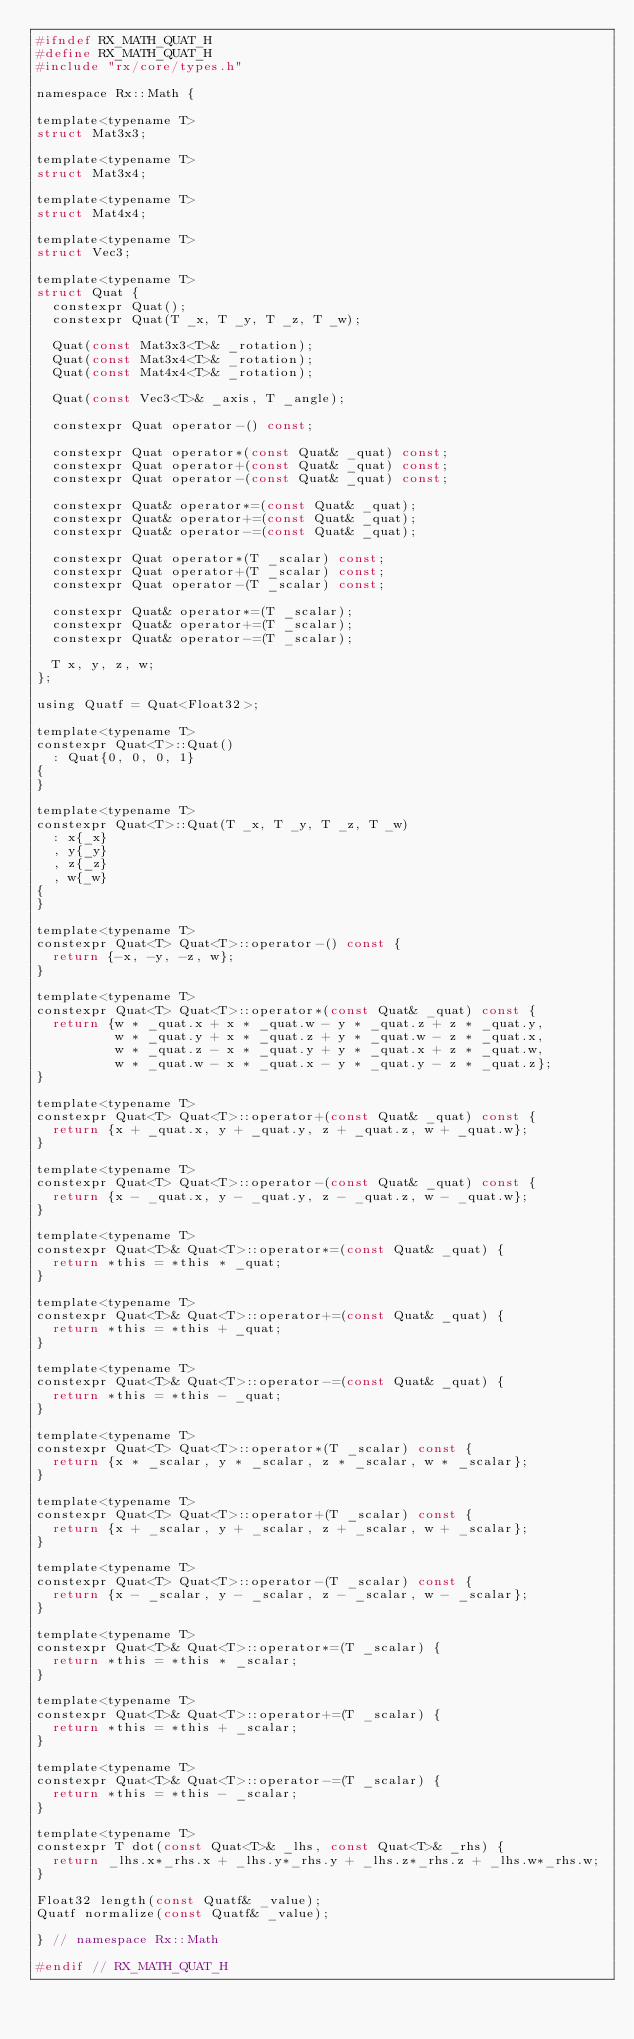Convert code to text. <code><loc_0><loc_0><loc_500><loc_500><_C_>#ifndef RX_MATH_QUAT_H
#define RX_MATH_QUAT_H
#include "rx/core/types.h"

namespace Rx::Math {

template<typename T>
struct Mat3x3;

template<typename T>
struct Mat3x4;

template<typename T>
struct Mat4x4;

template<typename T>
struct Vec3;

template<typename T>
struct Quat {
  constexpr Quat();
  constexpr Quat(T _x, T _y, T _z, T _w);

  Quat(const Mat3x3<T>& _rotation);
  Quat(const Mat3x4<T>& _rotation);
  Quat(const Mat4x4<T>& _rotation);

  Quat(const Vec3<T>& _axis, T _angle);

  constexpr Quat operator-() const;

  constexpr Quat operator*(const Quat& _quat) const;
  constexpr Quat operator+(const Quat& _quat) const;
  constexpr Quat operator-(const Quat& _quat) const;

  constexpr Quat& operator*=(const Quat& _quat);
  constexpr Quat& operator+=(const Quat& _quat);
  constexpr Quat& operator-=(const Quat& _quat);

  constexpr Quat operator*(T _scalar) const;
  constexpr Quat operator+(T _scalar) const;
  constexpr Quat operator-(T _scalar) const;

  constexpr Quat& operator*=(T _scalar);
  constexpr Quat& operator+=(T _scalar);
  constexpr Quat& operator-=(T _scalar);

  T x, y, z, w;
};

using Quatf = Quat<Float32>;

template<typename T>
constexpr Quat<T>::Quat()
  : Quat{0, 0, 0, 1}
{
}

template<typename T>
constexpr Quat<T>::Quat(T _x, T _y, T _z, T _w)
  : x{_x}
  , y{_y}
  , z{_z}
  , w{_w}
{
}

template<typename T>
constexpr Quat<T> Quat<T>::operator-() const {
  return {-x, -y, -z, w};
}

template<typename T>
constexpr Quat<T> Quat<T>::operator*(const Quat& _quat) const {
  return {w * _quat.x + x * _quat.w - y * _quat.z + z * _quat.y,
          w * _quat.y + x * _quat.z + y * _quat.w - z * _quat.x,
          w * _quat.z - x * _quat.y + y * _quat.x + z * _quat.w,
          w * _quat.w - x * _quat.x - y * _quat.y - z * _quat.z};
}

template<typename T>
constexpr Quat<T> Quat<T>::operator+(const Quat& _quat) const {
  return {x + _quat.x, y + _quat.y, z + _quat.z, w + _quat.w};
}

template<typename T>
constexpr Quat<T> Quat<T>::operator-(const Quat& _quat) const {
  return {x - _quat.x, y - _quat.y, z - _quat.z, w - _quat.w};
}

template<typename T>
constexpr Quat<T>& Quat<T>::operator*=(const Quat& _quat) {
  return *this = *this * _quat;
}

template<typename T>
constexpr Quat<T>& Quat<T>::operator+=(const Quat& _quat) {
  return *this = *this + _quat;
}

template<typename T>
constexpr Quat<T>& Quat<T>::operator-=(const Quat& _quat) {
  return *this = *this - _quat;
}

template<typename T>
constexpr Quat<T> Quat<T>::operator*(T _scalar) const {
  return {x * _scalar, y * _scalar, z * _scalar, w * _scalar};
}

template<typename T>
constexpr Quat<T> Quat<T>::operator+(T _scalar) const {
  return {x + _scalar, y + _scalar, z + _scalar, w + _scalar};
}

template<typename T>
constexpr Quat<T> Quat<T>::operator-(T _scalar) const {
  return {x - _scalar, y - _scalar, z - _scalar, w - _scalar};
}

template<typename T>
constexpr Quat<T>& Quat<T>::operator*=(T _scalar) {
  return *this = *this * _scalar;
}

template<typename T>
constexpr Quat<T>& Quat<T>::operator+=(T _scalar) {
  return *this = *this + _scalar;
}

template<typename T>
constexpr Quat<T>& Quat<T>::operator-=(T _scalar) {
  return *this = *this - _scalar;
}

template<typename T>
constexpr T dot(const Quat<T>& _lhs, const Quat<T>& _rhs) {
  return _lhs.x*_rhs.x + _lhs.y*_rhs.y + _lhs.z*_rhs.z + _lhs.w*_rhs.w;
}

Float32 length(const Quatf& _value);
Quatf normalize(const Quatf& _value);

} // namespace Rx::Math

#endif // RX_MATH_QUAT_H
</code> 